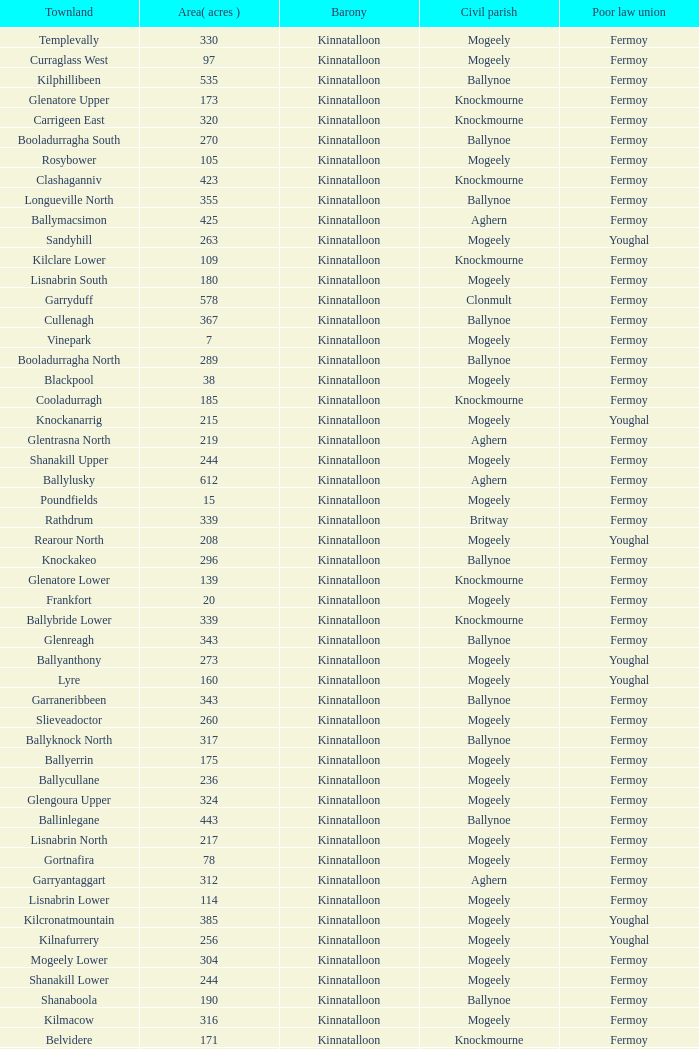Name  the townland for fermoy and ballynoe Ballinlegane, Ballinscurloge, Ballyknock, Ballyknock North, Ballyknock South, Ballymonteen, Ballynattin, Ballynoe, Booladurragha North, Booladurragha South, Cullenagh, Garraneribbeen, Glenreagh, Glentane, Killasseragh, Kilphillibeen, Knockakeo, Longueville North, Longueville South, Rathdrum, Shanaboola. 